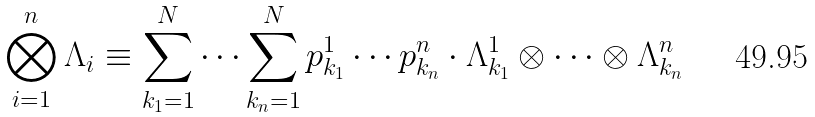<formula> <loc_0><loc_0><loc_500><loc_500>\bigotimes _ { i = 1 } ^ { n } \Lambda _ { i } \equiv \sum _ { k _ { 1 } = 1 } ^ { N } \cdots \sum _ { k _ { n } = 1 } ^ { N } p _ { k _ { 1 } } ^ { 1 } \cdots p _ { k _ { n } } ^ { n } \cdot \Lambda _ { k _ { 1 } } ^ { 1 } \otimes \cdots \otimes \Lambda _ { k _ { n } } ^ { n }</formula> 